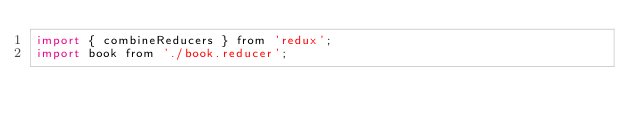<code> <loc_0><loc_0><loc_500><loc_500><_JavaScript_>import { combineReducers } from 'redux';
import book from './book.reducer';
</code> 